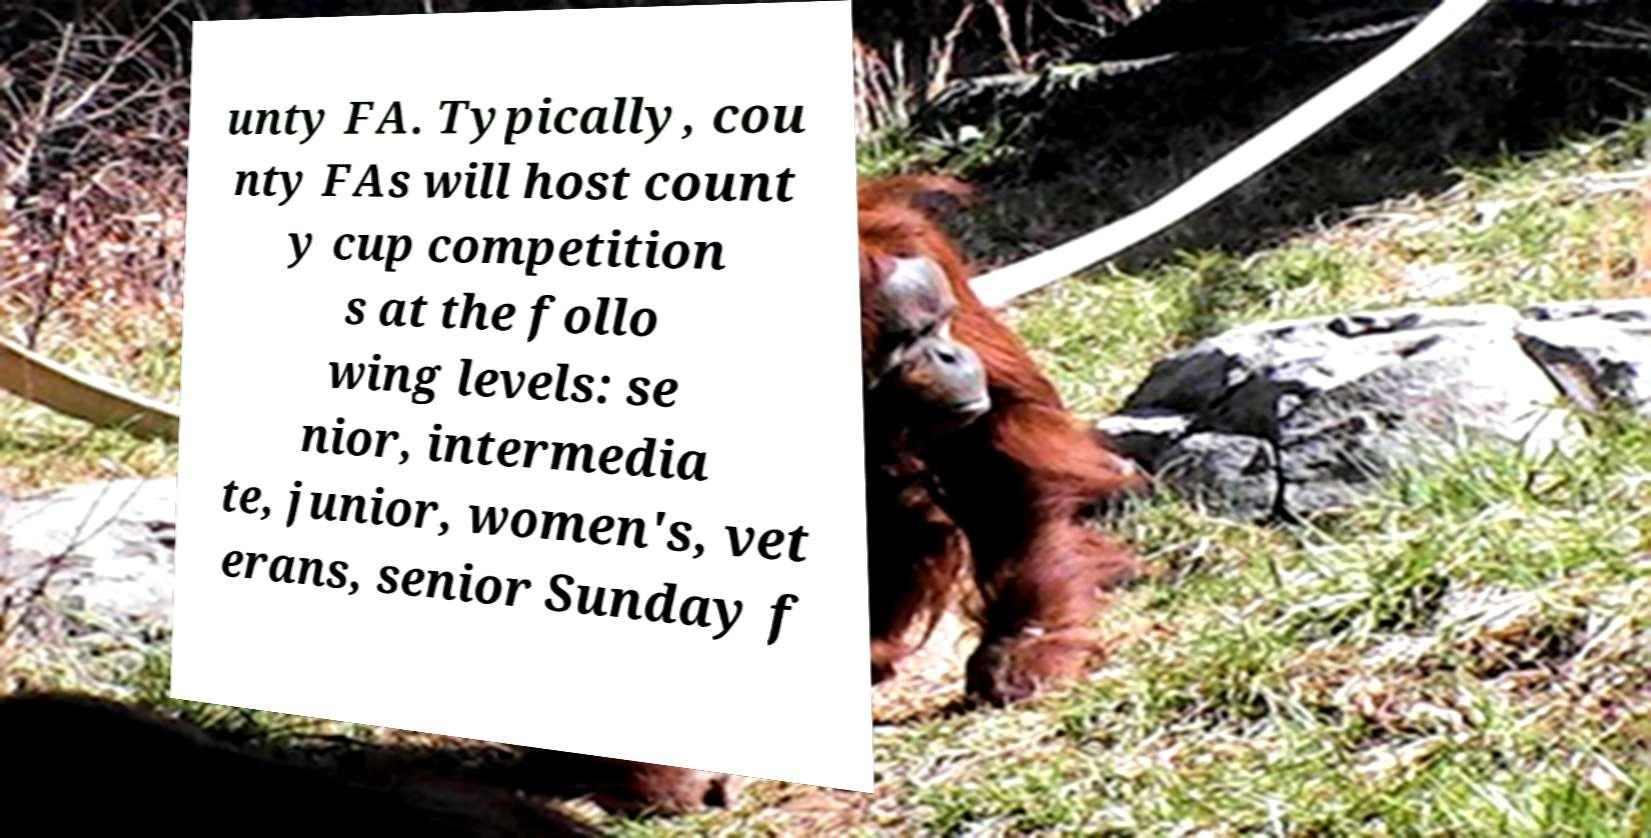What messages or text are displayed in this image? I need them in a readable, typed format. unty FA. Typically, cou nty FAs will host count y cup competition s at the follo wing levels: se nior, intermedia te, junior, women's, vet erans, senior Sunday f 